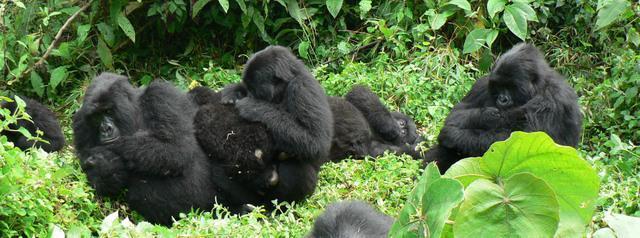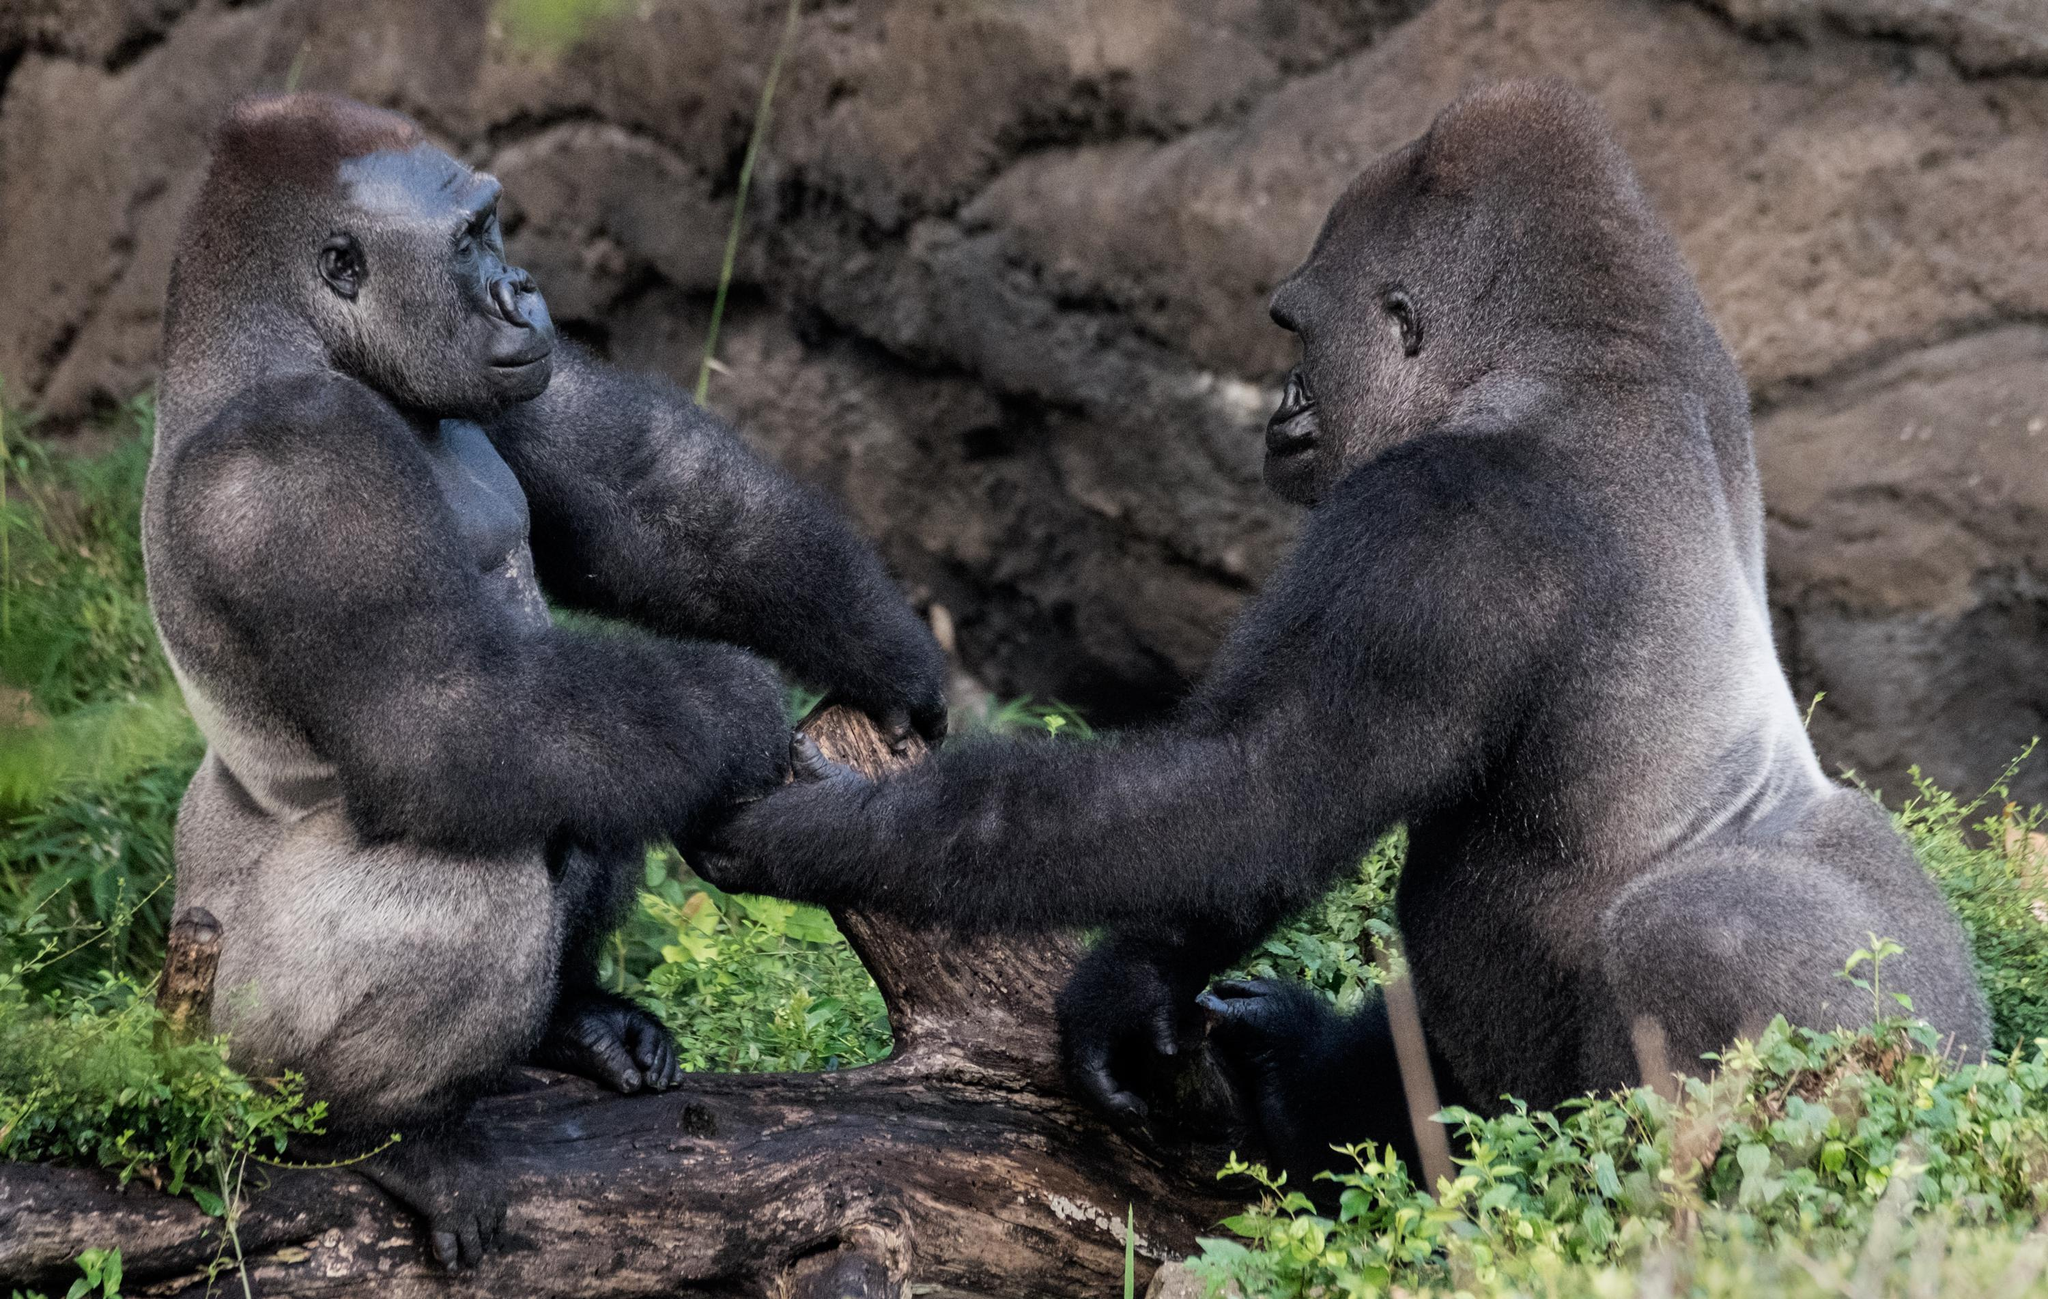The first image is the image on the left, the second image is the image on the right. Assess this claim about the two images: "An image contains exactly two gorillas, whose faces are only a few inches apart.". Correct or not? Answer yes or no. No. The first image is the image on the left, the second image is the image on the right. Examine the images to the left and right. Is the description "An adult gorilla is holding a baby gorilla in the right image." accurate? Answer yes or no. No. 